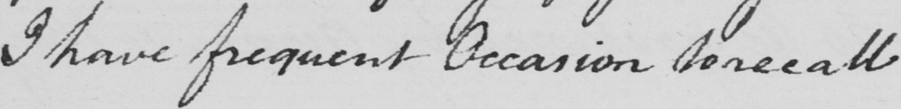Can you tell me what this handwritten text says? I have frequent Occasion to recall 